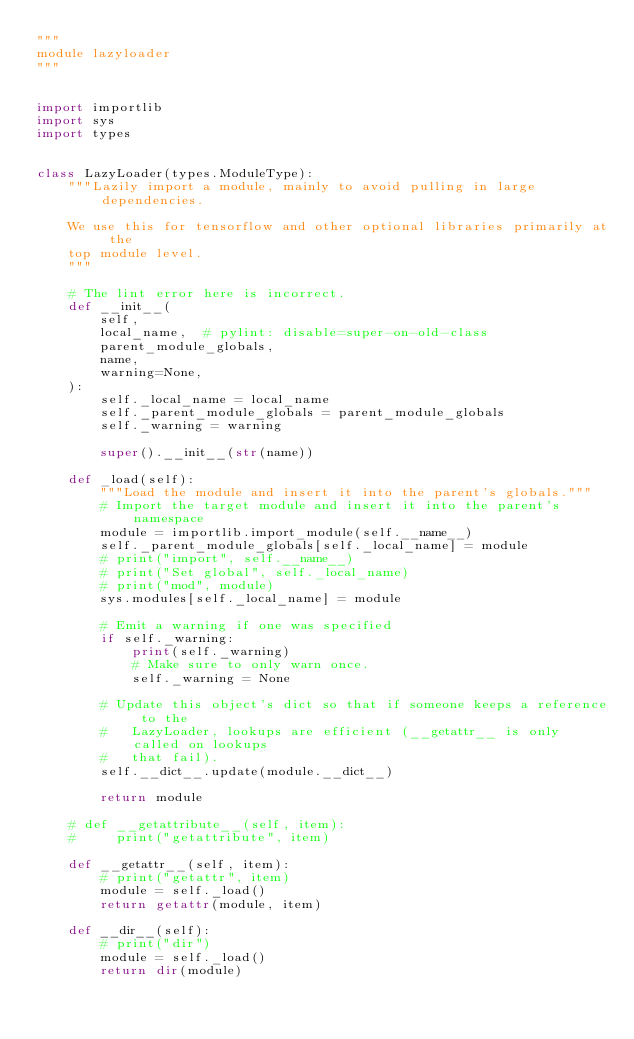<code> <loc_0><loc_0><loc_500><loc_500><_Python_>"""
module lazyloader
"""


import importlib
import sys
import types


class LazyLoader(types.ModuleType):
    """Lazily import a module, mainly to avoid pulling in large dependencies.

    We use this for tensorflow and other optional libraries primarily at the
    top module level.
    """

    # The lint error here is incorrect.
    def __init__(
        self,
        local_name,  # pylint: disable=super-on-old-class
        parent_module_globals,
        name,
        warning=None,
    ):
        self._local_name = local_name
        self._parent_module_globals = parent_module_globals
        self._warning = warning

        super().__init__(str(name))

    def _load(self):
        """Load the module and insert it into the parent's globals."""
        # Import the target module and insert it into the parent's namespace
        module = importlib.import_module(self.__name__)
        self._parent_module_globals[self._local_name] = module
        # print("import", self.__name__)
        # print("Set global", self._local_name)
        # print("mod", module)
        sys.modules[self._local_name] = module

        # Emit a warning if one was specified
        if self._warning:
            print(self._warning)
            # Make sure to only warn once.
            self._warning = None

        # Update this object's dict so that if someone keeps a reference to the
        #   LazyLoader, lookups are efficient (__getattr__ is only called on lookups
        #   that fail).
        self.__dict__.update(module.__dict__)

        return module

    # def __getattribute__(self, item):
    #     print("getattribute", item)

    def __getattr__(self, item):
        # print("getattr", item)
        module = self._load()
        return getattr(module, item)

    def __dir__(self):
        # print("dir")
        module = self._load()
        return dir(module)
</code> 